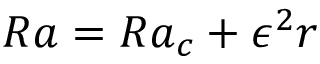Convert formula to latex. <formula><loc_0><loc_0><loc_500><loc_500>R a = R a _ { c } + \epsilon ^ { 2 } r</formula> 